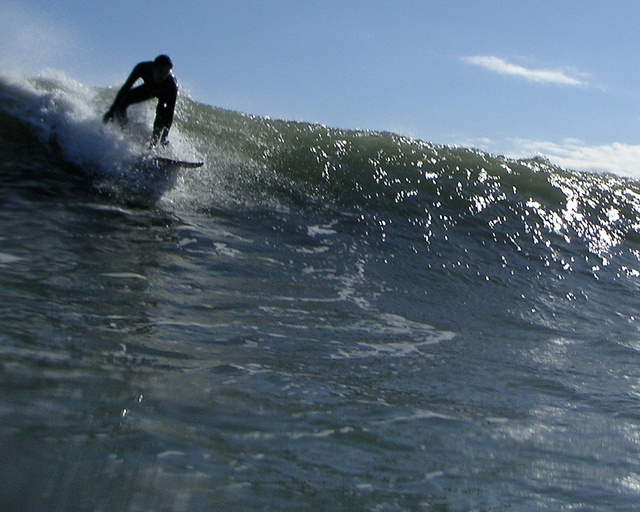Describe the objects in this image and their specific colors. I can see people in gray, black, darkgray, and blue tones and surfboard in gray and black tones in this image. 